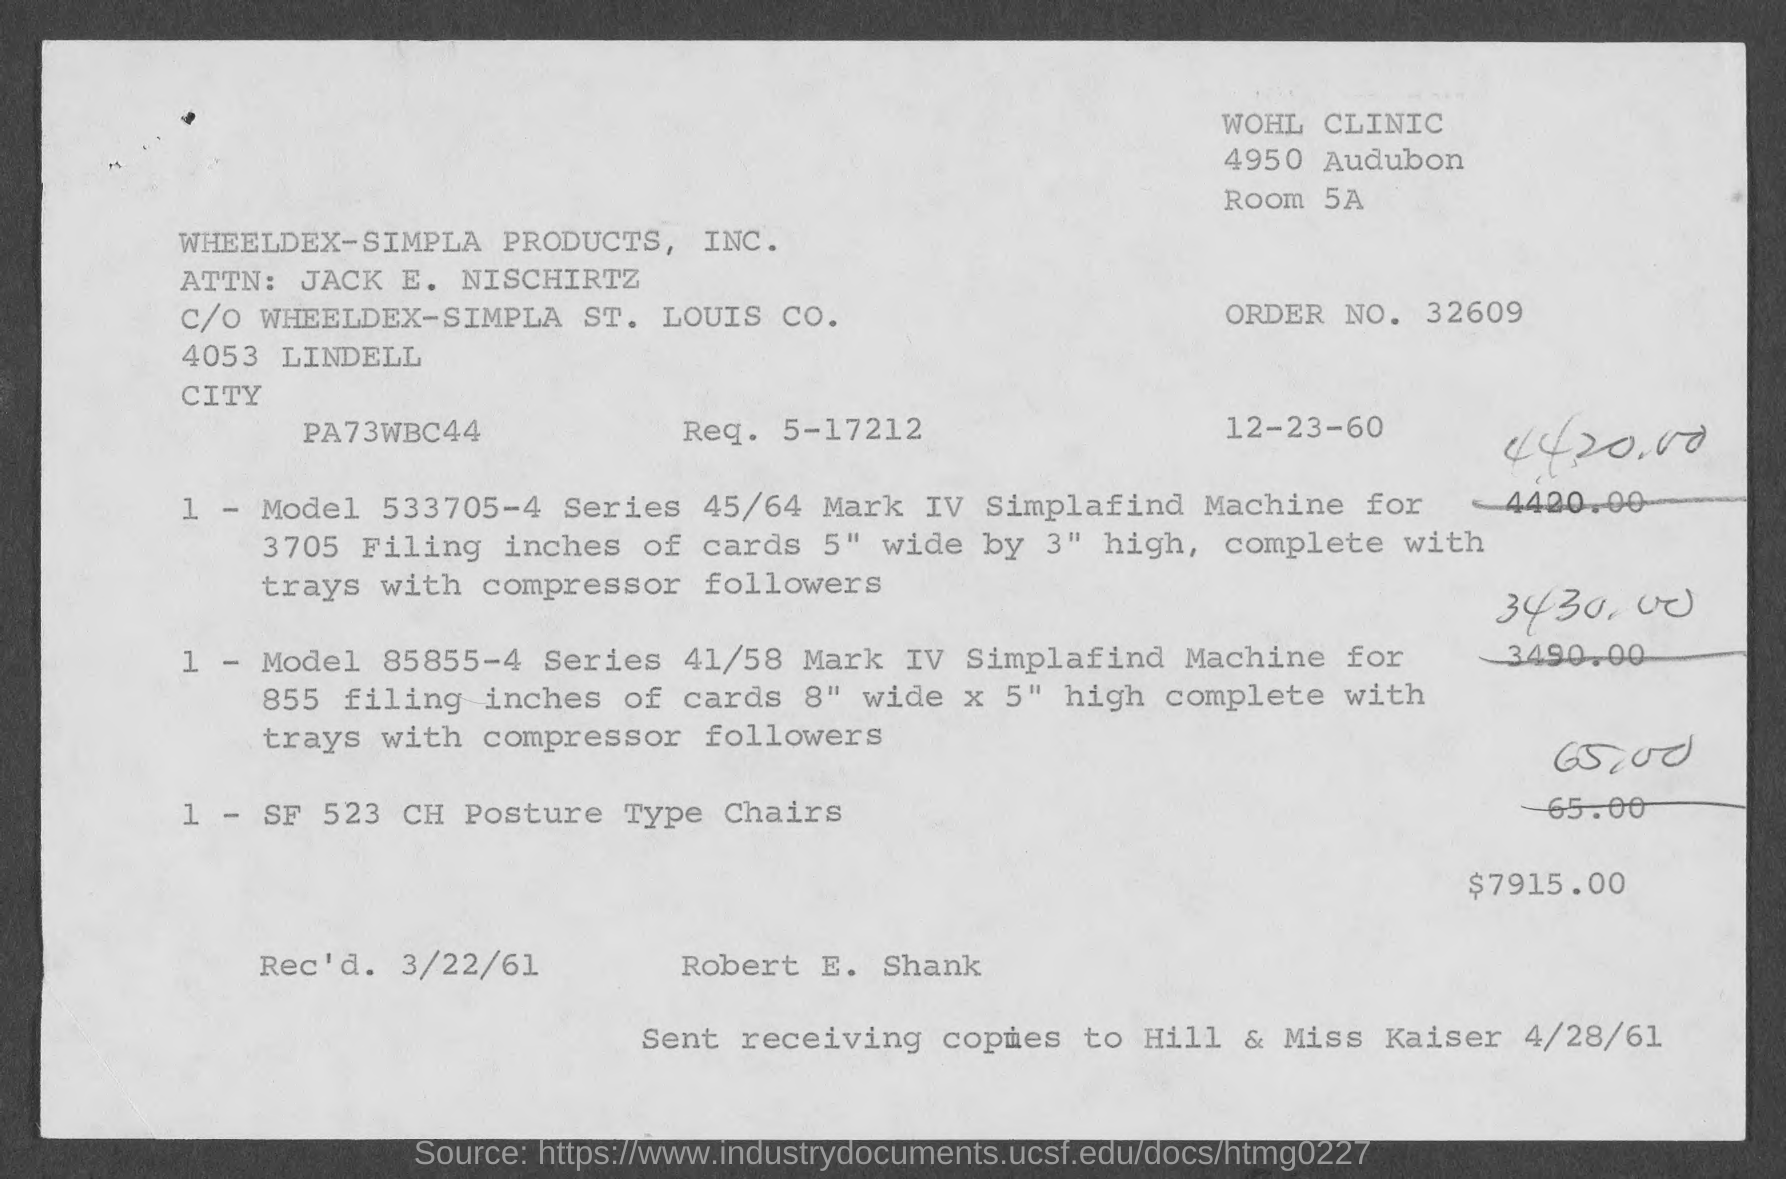What is the order no.?
Give a very brief answer. 32609. What is the room no.?
Give a very brief answer. 5A. 